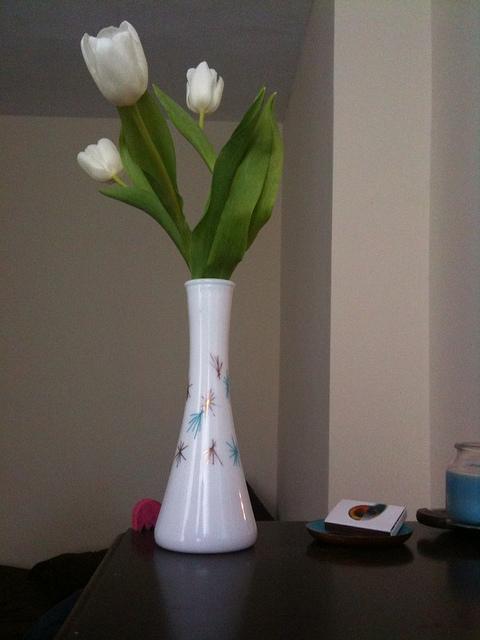Does the leaf have any tears in it?
Answer briefly. No. Is the vase on top of a crocheted cover?
Answer briefly. No. What kind of plant is in the background?
Be succinct. Tulip. What color flower is in the vase?
Be succinct. White. What kind of flowers are these?
Give a very brief answer. Tulips. Are these flowers artificial?
Short answer required. No. Is the flask being used for its original purpose?
Give a very brief answer. Yes. How many vases are there?
Quick response, please. 1. What color is the vase?
Keep it brief. White. Is this a Chinese vase?
Short answer required. No. What kind of flowers are there?
Concise answer only. Tulips. What do the flowers smell like?
Be succinct. Sweet. What type of flower is next to the lamp?
Concise answer only. Tulip. What color is the flower?
Be succinct. White. What colors are the feathers?
Keep it brief. Green. What is the object near the vase?
Short answer required. No. This type of flower could be used as a pun for what body parts?
Short answer required. Lips. Is this a restaurant table?
Concise answer only. No. How many forks are there?
Short answer required. 0. Do the flowers look fresh?
Give a very brief answer. Yes. Are these flowers real?
Keep it brief. Yes. What kind of flower is in the vase?
Be succinct. Tulip. What color is the rose?
Give a very brief answer. White. 